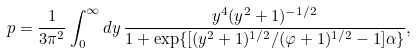<formula> <loc_0><loc_0><loc_500><loc_500>p = \frac { 1 } { 3 \pi ^ { 2 } } \int ^ { \infty } _ { 0 } d y \, \frac { y ^ { 4 } ( y ^ { 2 } + 1 ) ^ { - 1 / 2 } } { 1 + \exp \{ [ ( y ^ { 2 } + 1 ) ^ { 1 / 2 } / ( \varphi + 1 ) ^ { 1 / 2 } - 1 ] \alpha \} } ,</formula> 